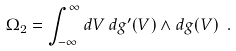Convert formula to latex. <formula><loc_0><loc_0><loc_500><loc_500>\Omega _ { 2 } = \int _ { - \infty } ^ { \infty } d V \, d g ^ { \prime } ( V ) \wedge d g ( V ) \ .</formula> 